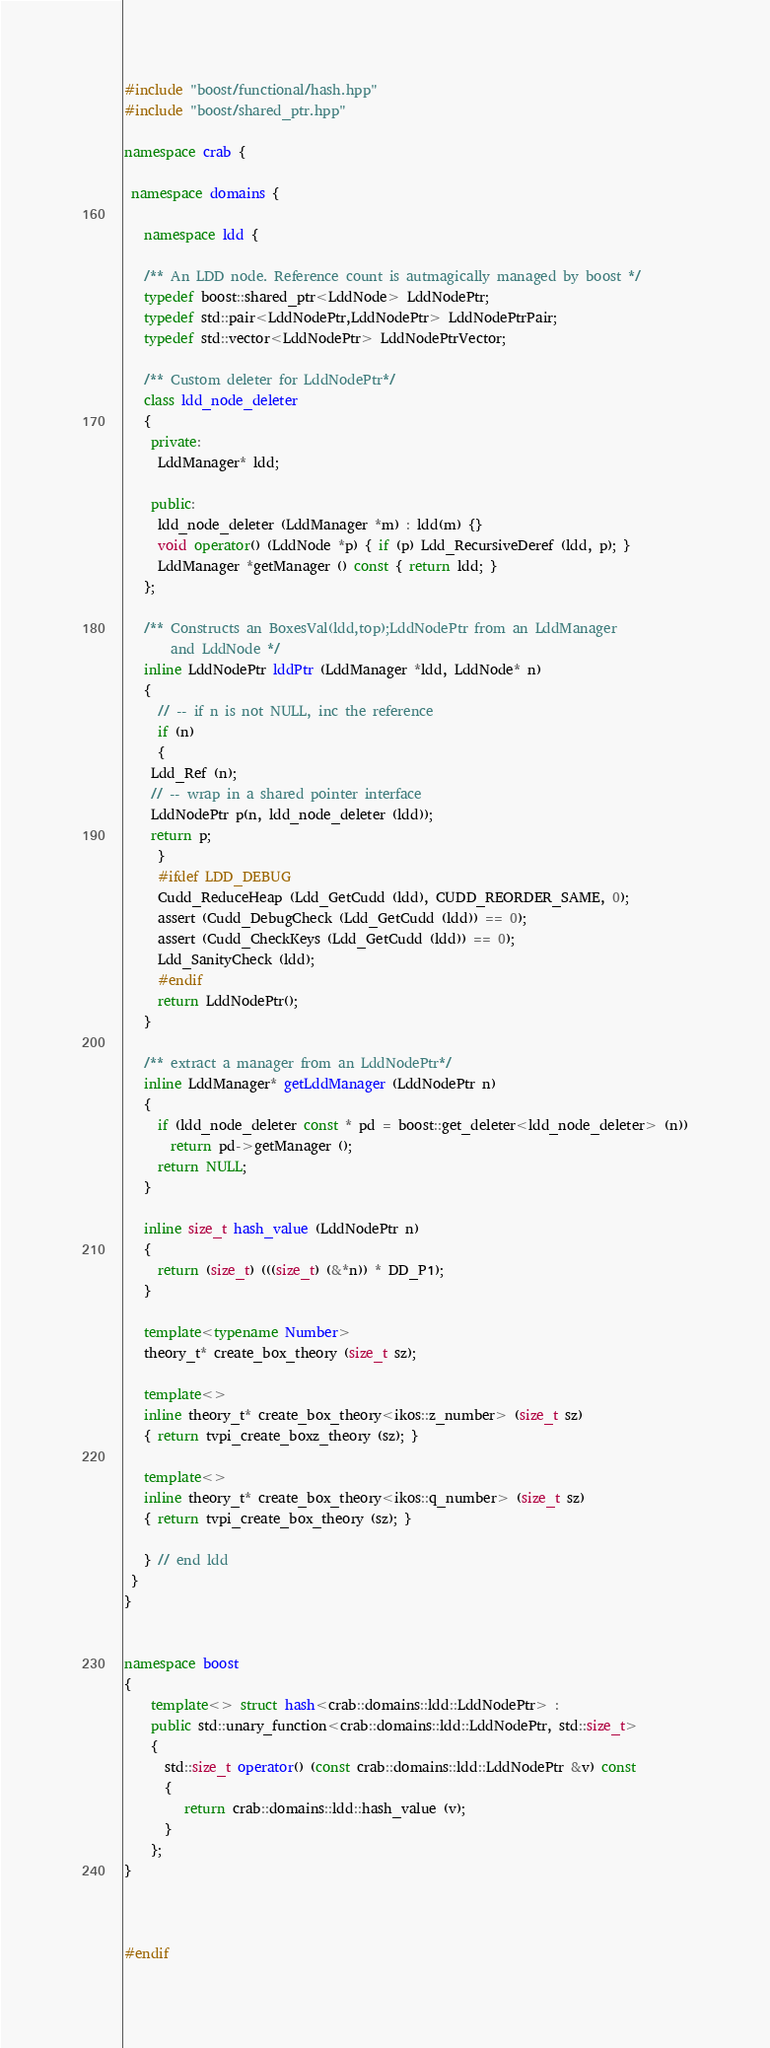<code> <loc_0><loc_0><loc_500><loc_500><_C++_>
#include "boost/functional/hash.hpp"
#include "boost/shared_ptr.hpp"

namespace crab {

 namespace domains {
  
   namespace ldd {

   /** An LDD node. Reference count is autmagically managed by boost */
   typedef boost::shared_ptr<LddNode> LddNodePtr;
   typedef std::pair<LddNodePtr,LddNodePtr> LddNodePtrPair;  
   typedef std::vector<LddNodePtr> LddNodePtrVector;
   
   /** Custom deleter for LddNodePtr*/
   class ldd_node_deleter
   {
    private:
     LddManager* ldd;
     
    public:
     ldd_node_deleter (LddManager *m) : ldd(m) {}
     void operator() (LddNode *p) { if (p) Ldd_RecursiveDeref (ldd, p); }  
     LddManager *getManager () const { return ldd; }
   };
   
   /** Constructs an BoxesVal(ldd,top);LddNodePtr from an LddManager
       and LddNode */
   inline LddNodePtr lddPtr (LddManager *ldd, LddNode* n)
   {
     // -- if n is not NULL, inc the reference
     if (n) 
     {
	Ldd_Ref (n);
	// -- wrap in a shared pointer interface
	LddNodePtr p(n, ldd_node_deleter (ldd));
	return p;
     }
     #ifdef LDD_DEBUG
     Cudd_ReduceHeap (Ldd_GetCudd (ldd), CUDD_REORDER_SAME, 0);
     assert (Cudd_DebugCheck (Ldd_GetCudd (ldd)) == 0);
     assert (Cudd_CheckKeys (Ldd_GetCudd (ldd)) == 0);
     Ldd_SanityCheck (ldd);
     #endif    
     return LddNodePtr();
   }
   
   /** extract a manager from an LddNodePtr*/
   inline LddManager* getLddManager (LddNodePtr n)
   {
     if (ldd_node_deleter const * pd = boost::get_deleter<ldd_node_deleter> (n))
       return pd->getManager ();
     return NULL;
   }
   
   inline size_t hash_value (LddNodePtr n)
   {
     return (size_t) (((size_t) (&*n)) * DD_P1);
   }

   template<typename Number>
   theory_t* create_box_theory (size_t sz);
     
   template<>
   inline theory_t* create_box_theory<ikos::z_number> (size_t sz)
   { return tvpi_create_boxz_theory (sz); }

   template<>
   inline theory_t* create_box_theory<ikos::q_number> (size_t sz)
   { return tvpi_create_box_theory (sz); }
     
   } // end ldd
 }
}


namespace boost
{
    template<> struct hash<crab::domains::ldd::LddNodePtr> : 
    public std::unary_function<crab::domains::ldd::LddNodePtr, std::size_t>
    {
      std::size_t operator() (const crab::domains::ldd::LddNodePtr &v) const
      {
         return crab::domains::ldd::hash_value (v);
      }
    };
}



#endif
</code> 